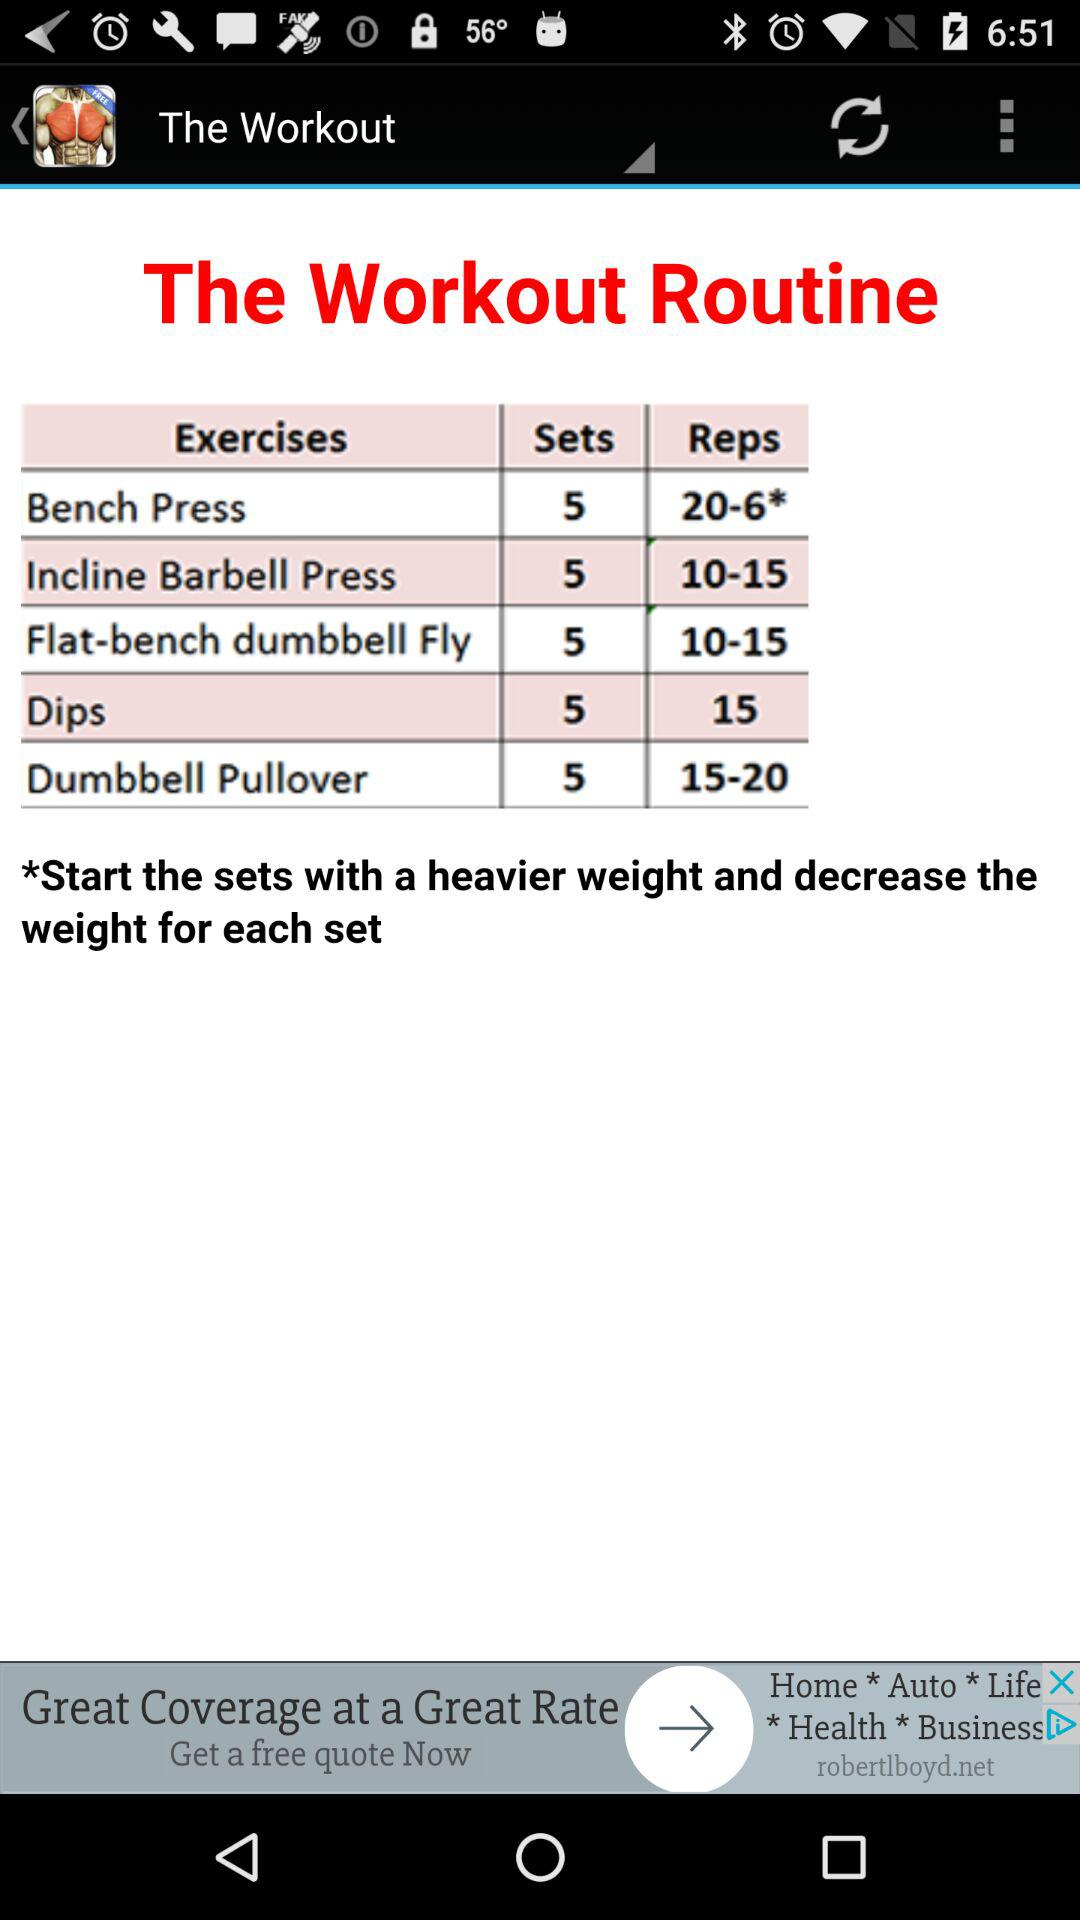How many sets are there in dips? There are 5 sets. 